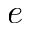<formula> <loc_0><loc_0><loc_500><loc_500>e</formula> 